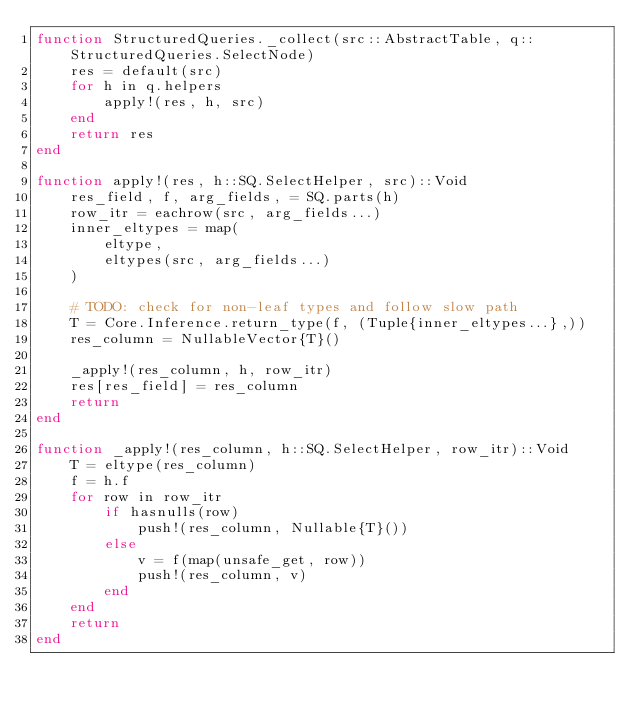<code> <loc_0><loc_0><loc_500><loc_500><_Julia_>function StructuredQueries._collect(src::AbstractTable, q::StructuredQueries.SelectNode)
    res = default(src)
    for h in q.helpers
        apply!(res, h, src)
    end
    return res
end

function apply!(res, h::SQ.SelectHelper, src)::Void
    res_field, f, arg_fields, = SQ.parts(h)
    row_itr = eachrow(src, arg_fields...)
    inner_eltypes = map(
        eltype,
        eltypes(src, arg_fields...)
    )

    # TODO: check for non-leaf types and follow slow path
    T = Core.Inference.return_type(f, (Tuple{inner_eltypes...},))
    res_column = NullableVector{T}()

    _apply!(res_column, h, row_itr)
    res[res_field] = res_column
    return
end

function _apply!(res_column, h::SQ.SelectHelper, row_itr)::Void
    T = eltype(res_column)
    f = h.f
    for row in row_itr
        if hasnulls(row)
            push!(res_column, Nullable{T}())
        else
            v = f(map(unsafe_get, row))
            push!(res_column, v)
        end
    end
    return
end
</code> 